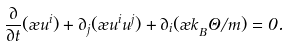<formula> <loc_0><loc_0><loc_500><loc_500>\frac { \partial } { \partial t } ( \rho u ^ { i } ) + \partial _ { j } ( \rho u ^ { i } u ^ { j } ) + \partial _ { i } ( \rho k _ { _ { B } } \Theta / m ) = 0 .</formula> 